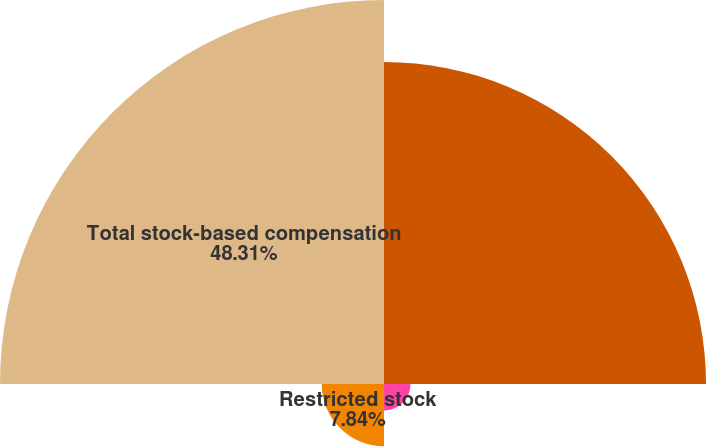Convert chart. <chart><loc_0><loc_0><loc_500><loc_500><pie_chart><fcel>Restricted stock and<fcel>Stock options<fcel>Restricted stock<fcel>Total stock-based compensation<nl><fcel>40.51%<fcel>3.34%<fcel>7.84%<fcel>48.31%<nl></chart> 